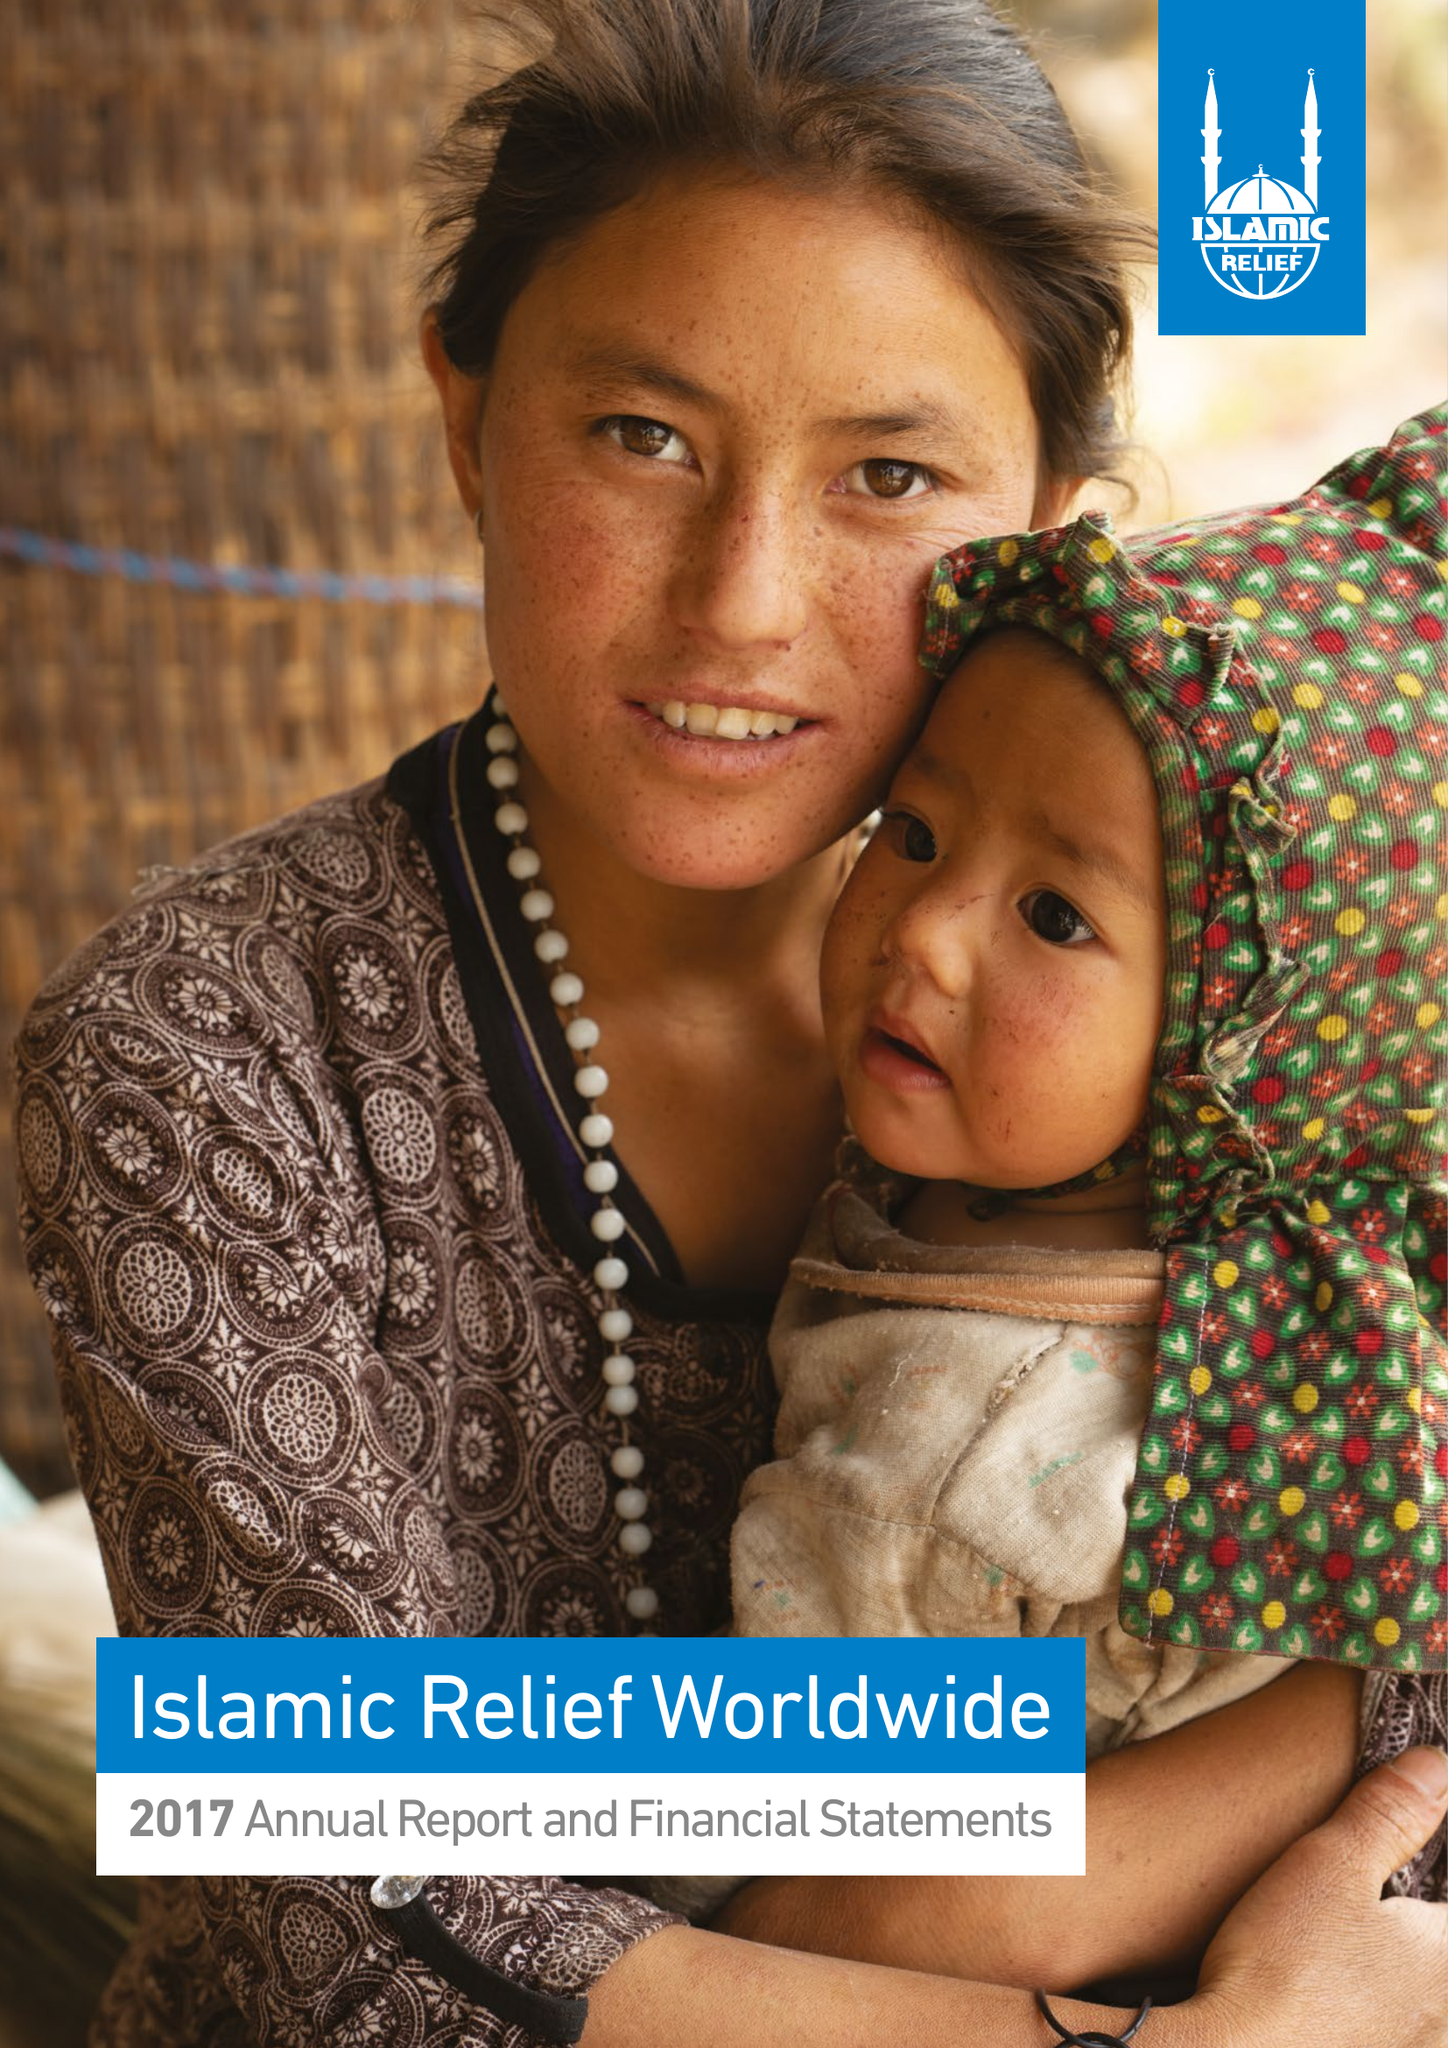What is the value for the address__postcode?
Answer the question using a single word or phrase. B5 6LB 